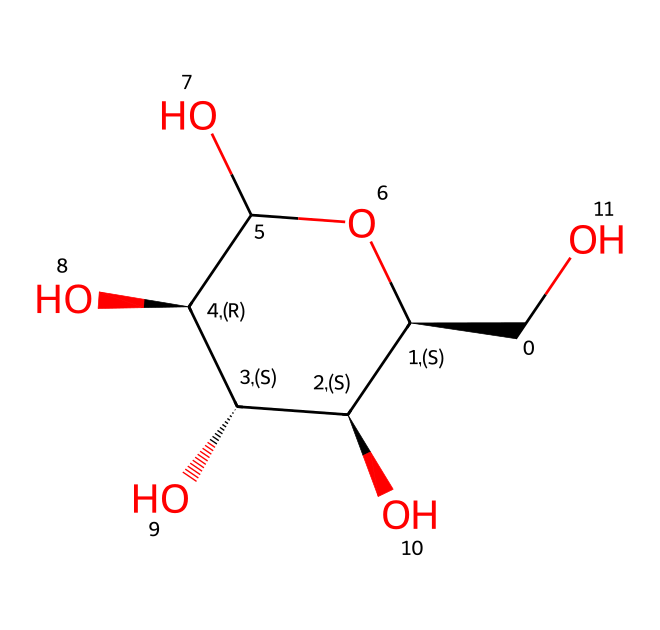How many oxygen atoms are present in this structure? By analyzing the SMILES representation, we can identify the oxygen atoms indicated by the "O" letters in the structure. Count the occurrences of "O" in the given SMILES. There are five "O" present in the structure.
Answer: five What is the name of this chemical compound? This SMILES string represents cellulose, which is a polysaccharide and a primary constituent of plant cell walls. The cyclic structure and arrangement indicate its identity as cellulose.
Answer: cellulose How many carbon atoms are present in this chemical? Looking at the SMILES representation, we can identify the carbon atoms indicated by the "C" letters. Counting all "C" instances in the structure gives us a total of six carbon atoms.
Answer: six What type of compound is cellulose classified as? Cellulose is classified as an aliphatic compound due to its carbon chain structure. It is a polysaccharide formed by the polymerization of glucose, which also possesses aliphatic characteristics.
Answer: aliphatic Which part of the structure indicates that it is a polysaccharide? The presence of multiple hydroxyl (-OH) groups and the repeating monomeric units (glucose molecules) indicates that this compound is a polysaccharide. The long chain formed by these repeating units confirms the identity.
Answer: repeating units What characteristic of cellulose contributes to its rigidity in paper and canvas? The extensive hydrogen bonding between the hydroxyl groups of cellulose molecules contributes to the rigidity and structural strength of cellulose, allowing it to provide stability in high-quality paper and canvas.
Answer: hydrogen bonding How many hydroxyl groups are there in this molecule? The "OH" groups in the SMILES representation indicate the presence of hydroxyl groups. Counting these occurrences gives us a total of four hydroxyl groups present in the molecule.
Answer: four 